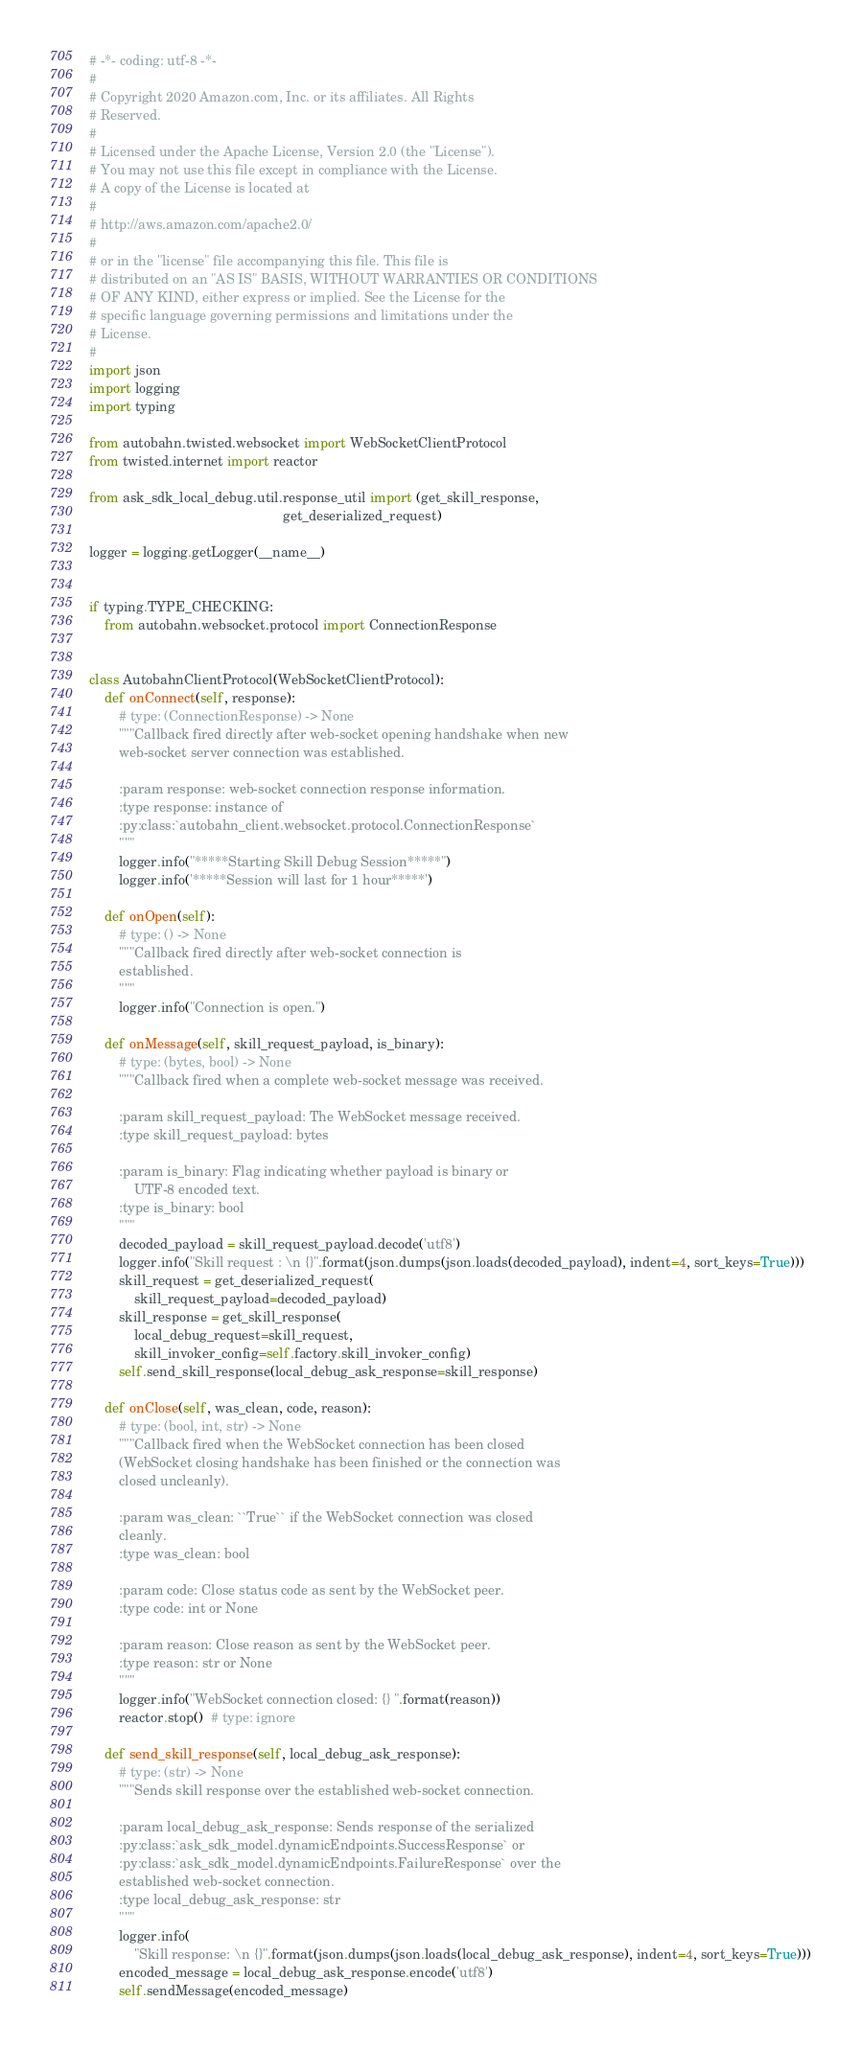Convert code to text. <code><loc_0><loc_0><loc_500><loc_500><_Python_># -*- coding: utf-8 -*-
#
# Copyright 2020 Amazon.com, Inc. or its affiliates. All Rights
# Reserved.
#
# Licensed under the Apache License, Version 2.0 (the "License").
# You may not use this file except in compliance with the License.
# A copy of the License is located at
#
# http://aws.amazon.com/apache2.0/
#
# or in the "license" file accompanying this file. This file is
# distributed on an "AS IS" BASIS, WITHOUT WARRANTIES OR CONDITIONS
# OF ANY KIND, either express or implied. See the License for the
# specific language governing permissions and limitations under the
# License.
#
import json
import logging
import typing

from autobahn.twisted.websocket import WebSocketClientProtocol
from twisted.internet import reactor

from ask_sdk_local_debug.util.response_util import (get_skill_response,
                                                    get_deserialized_request)

logger = logging.getLogger(__name__)


if typing.TYPE_CHECKING:
    from autobahn.websocket.protocol import ConnectionResponse


class AutobahnClientProtocol(WebSocketClientProtocol):
    def onConnect(self, response):
        # type: (ConnectionResponse) -> None
        """Callback fired directly after web-socket opening handshake when new
        web-socket server connection was established.

        :param response: web-socket connection response information.
        :type response: instance of
        :py:class:`autobahn_client.websocket.protocol.ConnectionResponse`
        """
        logger.info("*****Starting Skill Debug Session*****")
        logger.info('*****Session will last for 1 hour*****')

    def onOpen(self):
        # type: () -> None
        """Callback fired directly after web-socket connection is
        established.
        """
        logger.info("Connection is open.")

    def onMessage(self, skill_request_payload, is_binary):
        # type: (bytes, bool) -> None
        """Callback fired when a complete web-socket message was received.

        :param skill_request_payload: The WebSocket message received.
        :type skill_request_payload: bytes

        :param is_binary: Flag indicating whether payload is binary or
            UTF-8 encoded text.
        :type is_binary: bool
        """
        decoded_payload = skill_request_payload.decode('utf8')
        logger.info("Skill request : \n {}".format(json.dumps(json.loads(decoded_payload), indent=4, sort_keys=True)))
        skill_request = get_deserialized_request(
            skill_request_payload=decoded_payload)
        skill_response = get_skill_response(
            local_debug_request=skill_request,
            skill_invoker_config=self.factory.skill_invoker_config)
        self.send_skill_response(local_debug_ask_response=skill_response)

    def onClose(self, was_clean, code, reason):
        # type: (bool, int, str) -> None
        """Callback fired when the WebSocket connection has been closed
        (WebSocket closing handshake has been finished or the connection was
        closed uncleanly).

        :param was_clean: ``True`` if the WebSocket connection was closed
        cleanly.
        :type was_clean: bool

        :param code: Close status code as sent by the WebSocket peer.
        :type code: int or None

        :param reason: Close reason as sent by the WebSocket peer.
        :type reason: str or None
        """
        logger.info("WebSocket connection closed: {} ".format(reason))
        reactor.stop()  # type: ignore

    def send_skill_response(self, local_debug_ask_response):
        # type: (str) -> None
        """Sends skill response over the established web-socket connection.

        :param local_debug_ask_response: Sends response of the serialized
        :py:class:`ask_sdk_model.dynamicEndpoints.SuccessResponse` or
        :py:class:`ask_sdk_model.dynamicEndpoints.FailureResponse` over the
        established web-socket connection.
        :type local_debug_ask_response: str
        """
        logger.info(
            "Skill response: \n {}".format(json.dumps(json.loads(local_debug_ask_response), indent=4, sort_keys=True)))
        encoded_message = local_debug_ask_response.encode('utf8')
        self.sendMessage(encoded_message)
</code> 